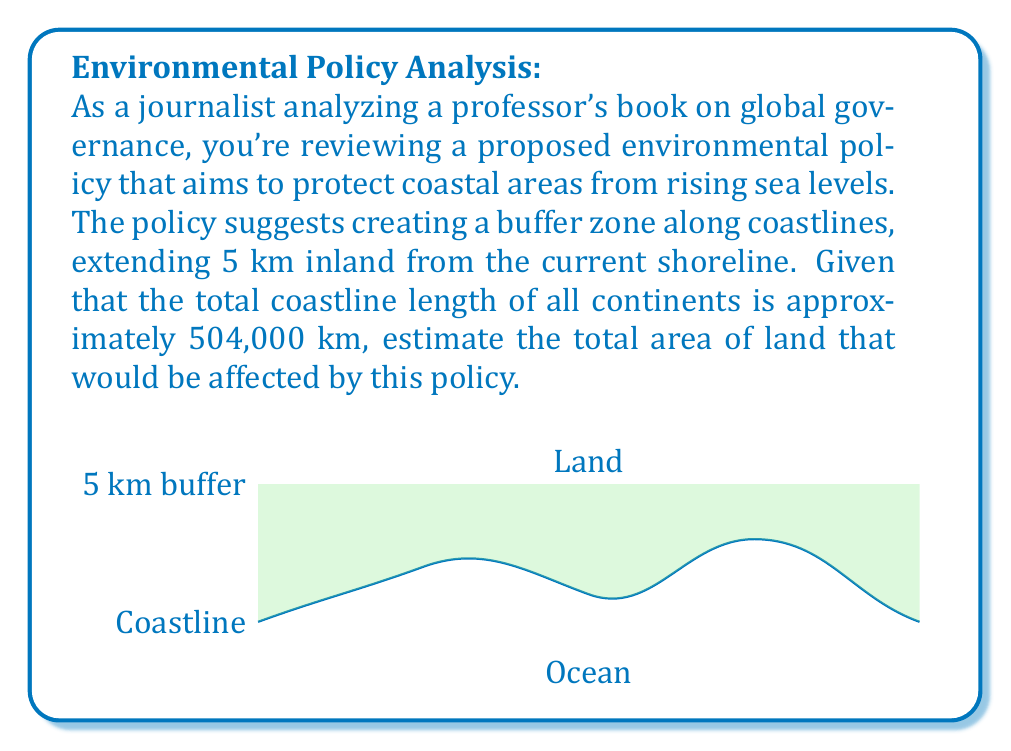What is the answer to this math problem? To estimate the total area affected by the proposed policy, we need to calculate the area of a strip of land that follows the coastline. This can be approximated as a rectangle, where:

1. The length is the total coastline length: 504,000 km
2. The width is the buffer zone depth: 5 km

The area of a rectangle is given by the formula:

$$A = l \times w$$

Where:
$A$ = Area
$l$ = Length
$w$ = Width

Substituting our values:

$$A = 504,000 \text{ km} \times 5 \text{ km}$$

$$A = 2,520,000 \text{ km}^2$$

To put this in perspective, we can convert it to million square kilometers:

$$2,520,000 \text{ km}^2 = 2.52 \text{ million km}^2$$

This area is roughly equivalent to the size of Saudi Arabia (2.15 million km²) or slightly larger than Mexico (1.96 million km²).

It's important to note that this is a simplified estimation. In reality, coastlines are irregular, and the affected area might vary due to factors such as coastal geography and population density.
Answer: 2.52 million km² 